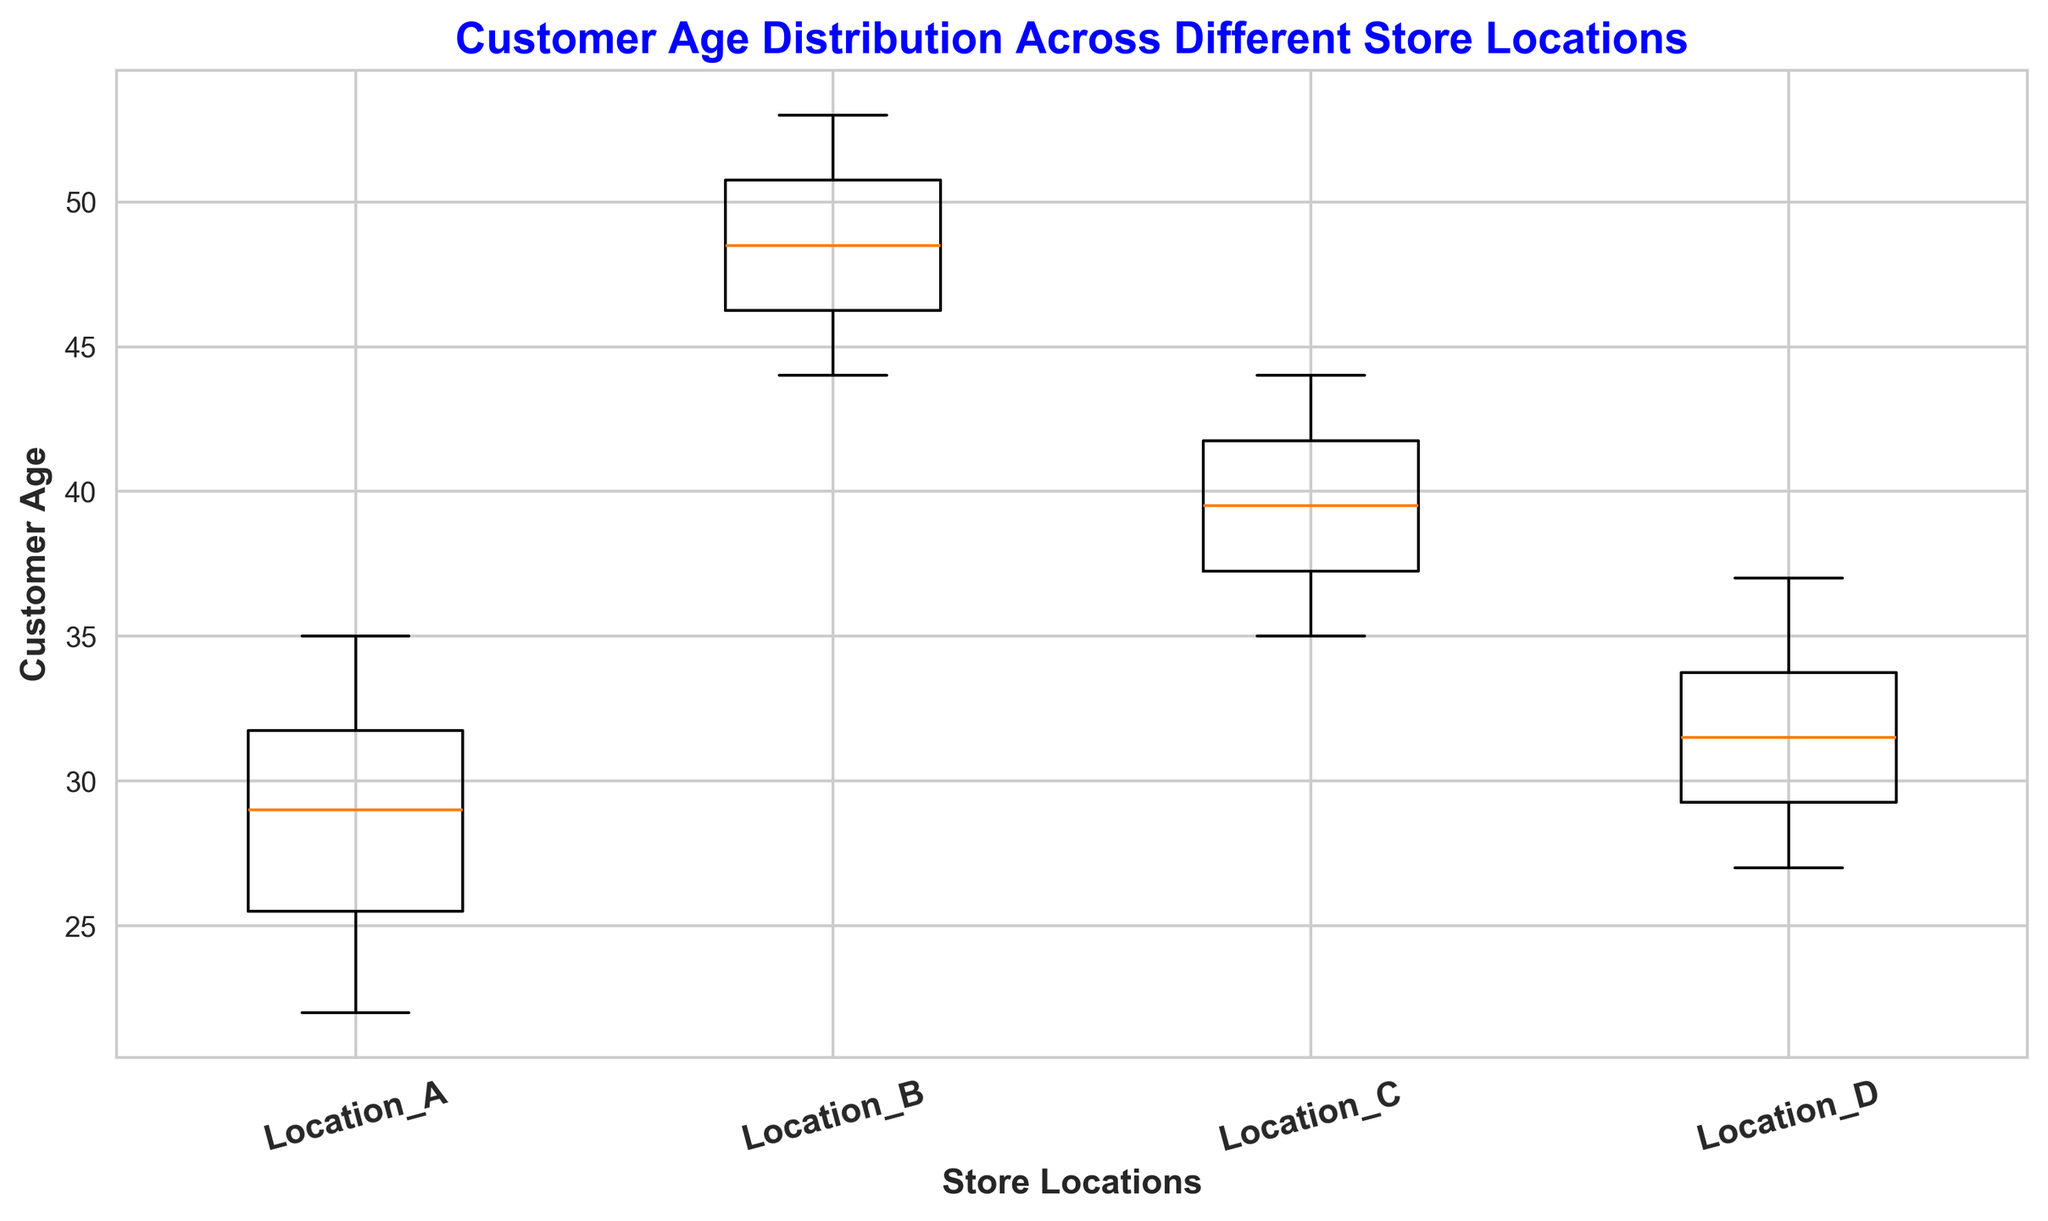What's the median customer age at Location B? To find the median value from a box plot, you look at the line inside the box for the specific location. For Location B, the median age is around the middle value of the sorted ages. From the visual, it appears to be 48.
Answer: 48 Which store location has the widest age distribution? To determine the widest age distribution, look at the length of the boxes and the whiskers. The larger the spread, the wider the distribution. Location B has the widest age distribution because the range is the largest from the lowest (44) to the highest (53).
Answer: Location B Is the median customer age at Location D greater or less than at Location A? The median is shown as the line inside each box. For Location D, it looks around 31, and for Location A, it is around 28. Therefore, the median age at Location D is greater than at Location A.
Answer: Greater Which location has the lowest median customer age? The median for each location can be identified by looking at the middle line inside the box. For Location A, it’s around 28, which is lower than the medians of the other locations. So, Location A has the lowest median age.
Answer: Location A What is the age range (difference between max and min) of customers at Location C? To find the age range, look at the ends of the whiskers for the maximum and minimum values. For Location C, the max looks at around 44, and the min looks at around 35. The age range is 44 - 35 = 9.
Answer: 9 Compare the upper quartile of Location A with Location D. Which is higher? The upper quartile (75th percentile) is the top line of the box. For Location A, it appears to be around 32 and for Location D, it’s around 34. Therefore, Location D's upper quartile is higher.
Answer: Location D Which store has the most consistent customer age (smallest spread)? The consistency of customer age is determined by the length of the interquartile range (IQR), which is the height of the box plot. Location A has the smallest IQR, indicating it has the most consistent customer age.
Answer: Location A Is there any store location where the median age is more than 50? To determine this, look at the median line inside the box for all locations. None of the locations show a median age line that is above 50.
Answer: No 